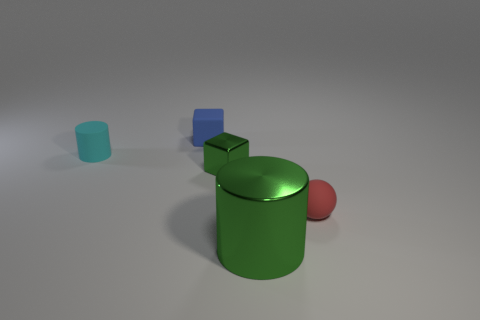Add 3 cyan objects. How many objects exist? 8 Subtract all blocks. How many objects are left? 3 Add 1 blue objects. How many blue objects are left? 2 Add 1 tiny blue matte cubes. How many tiny blue matte cubes exist? 2 Subtract 1 green cubes. How many objects are left? 4 Subtract all shiny objects. Subtract all green cubes. How many objects are left? 2 